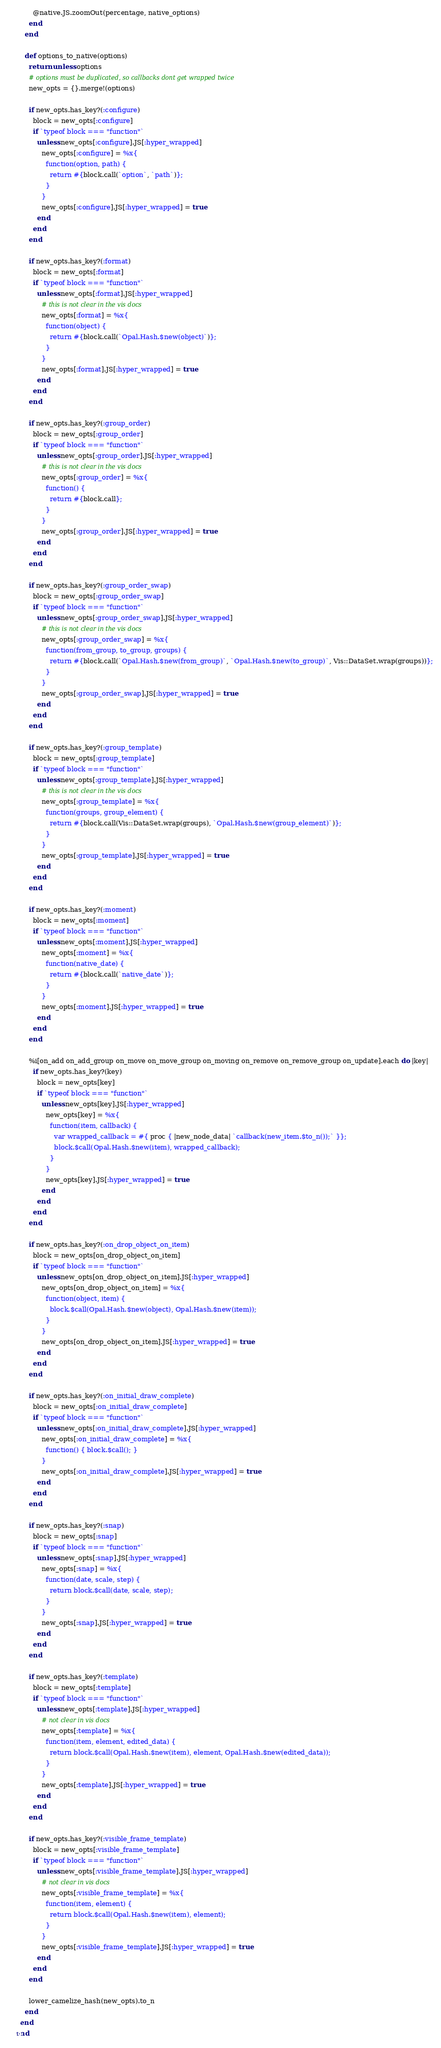<code> <loc_0><loc_0><loc_500><loc_500><_Ruby_>        @native.JS.zoomOut(percentage, native_options)
      end
    end

    def options_to_native(options)
      return unless options
      # options must be duplicated, so callbacks dont get wrapped twice
      new_opts = {}.merge!(options)

      if new_opts.has_key?(:configure)
        block = new_opts[:configure]
        if `typeof block === "function"`
          unless new_opts[:configure].JS[:hyper_wrapped]
            new_opts[:configure] = %x{
              function(option, path) {
                return #{block.call(`option`, `path`)};
              }
            }
            new_opts[:configure].JS[:hyper_wrapped] = true
          end
        end
      end

      if new_opts.has_key?(:format)
        block = new_opts[:format]
        if `typeof block === "function"`
          unless new_opts[:format].JS[:hyper_wrapped]
            # this is not clear in the vis docs
            new_opts[:format] = %x{
              function(object) {
                return #{block.call(`Opal.Hash.$new(object)`)};
              }
            }
            new_opts[:format].JS[:hyper_wrapped] = true
          end
        end
      end

      if new_opts.has_key?(:group_order)
        block = new_opts[:group_order]
        if `typeof block === "function"`
          unless new_opts[:group_order].JS[:hyper_wrapped]
            # this is not clear in the vis docs
            new_opts[:group_order] = %x{
              function() {
                return #{block.call};
              }
            }
            new_opts[:group_order].JS[:hyper_wrapped] = true
          end
        end
      end

      if new_opts.has_key?(:group_order_swap)
        block = new_opts[:group_order_swap]
        if `typeof block === "function"`
          unless new_opts[:group_order_swap].JS[:hyper_wrapped]
            # this is not clear in the vis docs
            new_opts[:group_order_swap] = %x{
              function(from_group, to_group, groups) {
                return #{block.call(`Opal.Hash.$new(from_group)`, `Opal.Hash.$new(to_group)`, Vis::DataSet.wrap(groups))};
              }
            }
            new_opts[:group_order_swap].JS[:hyper_wrapped] = true
          end
        end
      end

      if new_opts.has_key?(:group_template)
        block = new_opts[:group_template]
        if `typeof block === "function"`
          unless new_opts[:group_template].JS[:hyper_wrapped]
            # this is not clear in the vis docs
            new_opts[:group_template] = %x{
              function(groups, group_element) {
                return #{block.call(Vis::DataSet.wrap(groups), `Opal.Hash.$new(group_element)`)};
              }
            }
            new_opts[:group_template].JS[:hyper_wrapped] = true
          end
        end
      end

      if new_opts.has_key?(:moment)
        block = new_opts[:moment]
        if `typeof block === "function"`
          unless new_opts[:moment].JS[:hyper_wrapped]
            new_opts[:moment] = %x{
              function(native_date) {
                return #{block.call(`native_date`)};
              }
            }
            new_opts[:moment].JS[:hyper_wrapped] = true
          end
        end
      end

      %i[on_add on_add_group on_move on_move_group on_moving on_remove on_remove_group on_update].each do |key|
        if new_opts.has_key?(key)
          block = new_opts[key]
          if `typeof block === "function"`
            unless new_opts[key].JS[:hyper_wrapped]
              new_opts[key] = %x{
                function(item, callback) {
                  var wrapped_callback = #{ proc { |new_node_data| `callback(new_item.$to_n());` }};
                  block.$call(Opal.Hash.$new(item), wrapped_callback);
                }
              }
              new_opts[key].JS[:hyper_wrapped] = true
            end
          end
        end
      end

      if new_opts.has_key?(:on_drop_object_on_item)
        block = new_opts[on_drop_object_on_item]
        if `typeof block === "function"`
          unless new_opts[on_drop_object_on_item].JS[:hyper_wrapped]
            new_opts[on_drop_object_on_item] = %x{
              function(object, item) {
                block.$call(Opal.Hash.$new(object), Opal.Hash.$new(item));
              }
            }
            new_opts[on_drop_object_on_item].JS[:hyper_wrapped] = true
          end
        end
      end

      if new_opts.has_key?(:on_initial_draw_complete)
        block = new_opts[:on_initial_draw_complete]
        if `typeof block === "function"`
          unless new_opts[:on_initial_draw_complete].JS[:hyper_wrapped]
            new_opts[:on_initial_draw_complete] = %x{
              function() { block.$call(); }
            }
            new_opts[:on_initial_draw_complete].JS[:hyper_wrapped] = true
          end
        end
      end

      if new_opts.has_key?(:snap)
        block = new_opts[:snap]
        if `typeof block === "function"`
          unless new_opts[:snap].JS[:hyper_wrapped]
            new_opts[:snap] = %x{
              function(date, scale, step) {
                return block.$call(date, scale, step);
              }
            }
            new_opts[:snap].JS[:hyper_wrapped] = true
          end
        end
      end

      if new_opts.has_key?(:template)
        block = new_opts[:template]
        if `typeof block === "function"`
          unless new_opts[:template].JS[:hyper_wrapped]
            # not clear in vis docs
            new_opts[:template] = %x{
              function(item, element, edited_data) {
                return block.$call(Opal.Hash.$new(item), element, Opal.Hash.$new(edited_data));
              }
            }
            new_opts[:template].JS[:hyper_wrapped] = true
          end
        end
      end

      if new_opts.has_key?(:visible_frame_template)
        block = new_opts[:visible_frame_template]
        if `typeof block === "function"`
          unless new_opts[:visible_frame_template].JS[:hyper_wrapped]
            # not clear in vis docs
            new_opts[:visible_frame_template] = %x{
              function(item, element) {
                return block.$call(Opal.Hash.$new(item), element);
              }
            }
            new_opts[:visible_frame_template].JS[:hyper_wrapped] = true
          end
        end
      end

      lower_camelize_hash(new_opts).to_n
    end
  end
end</code> 